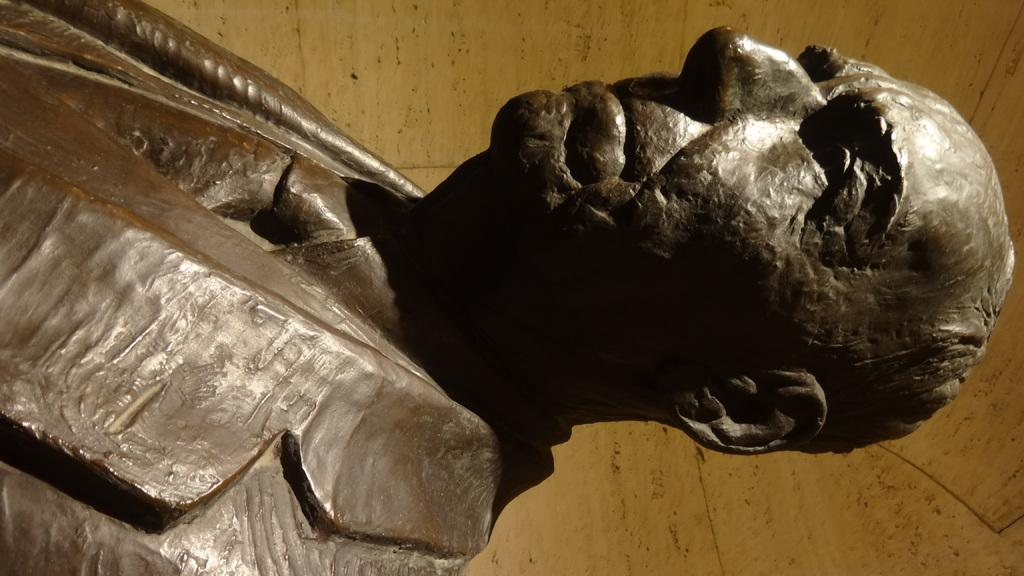What is the main subject of the image? There is a statue in the image. Can you describe the statue? The statue is of a man. What type of plastic material is covering the statue during the rainstorm in the image? There is no plastic material or rainstorm present in the image; it features a statue of a man. 